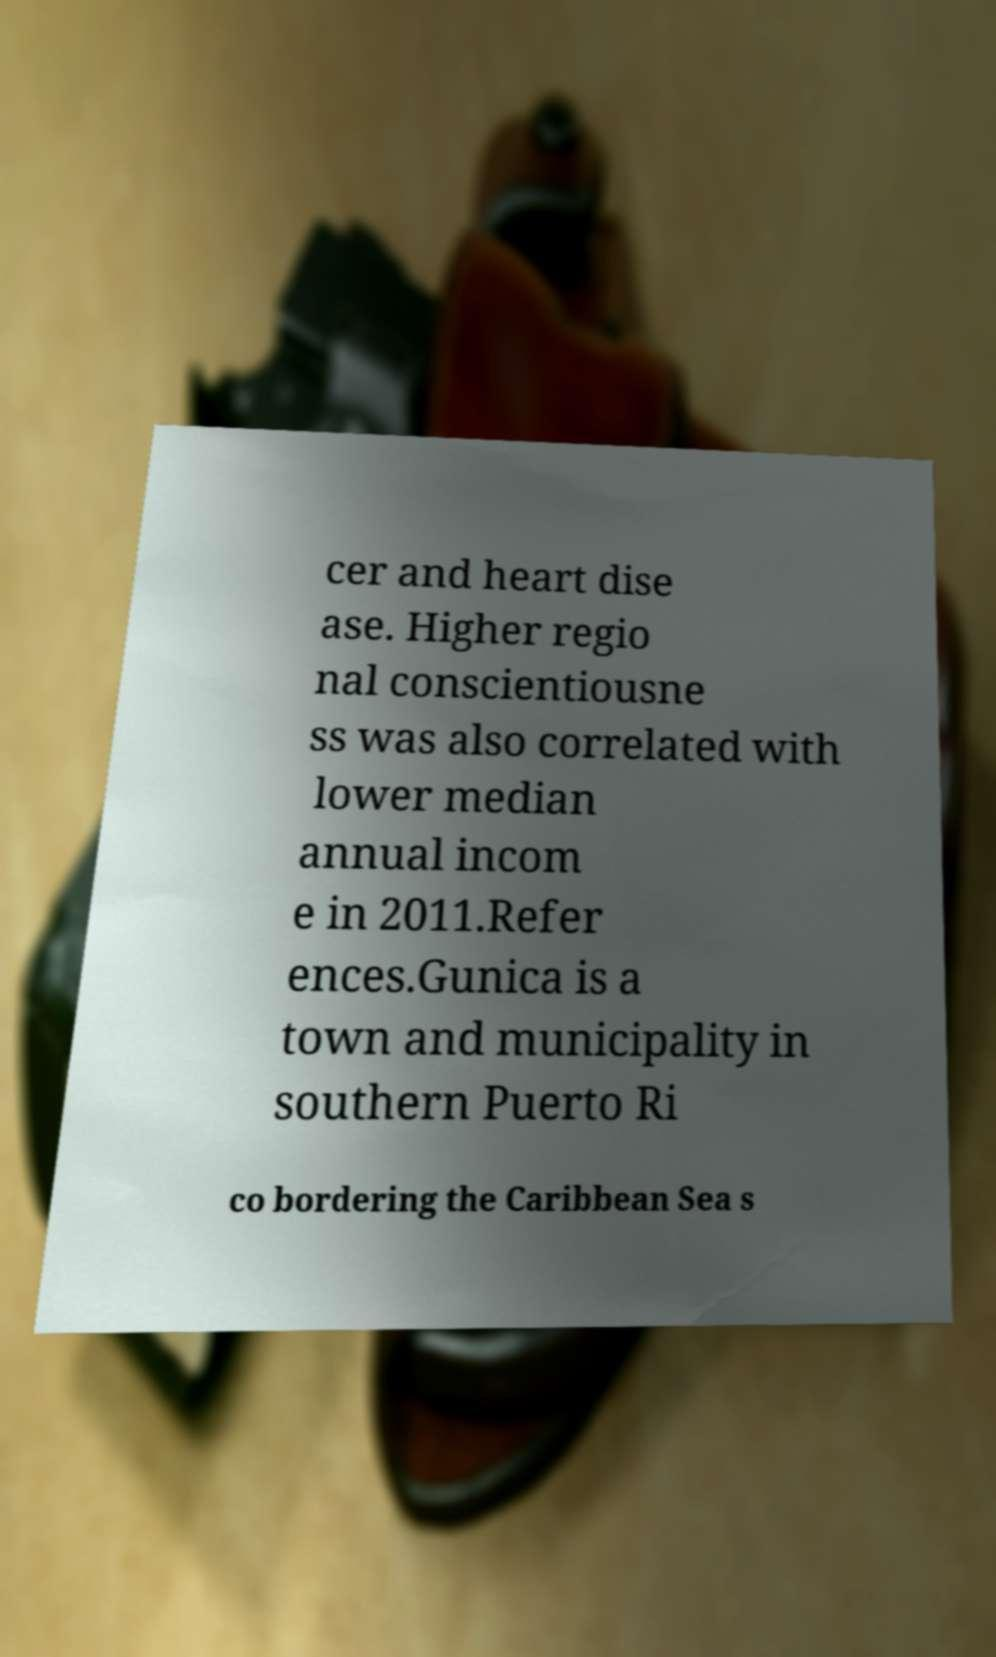For documentation purposes, I need the text within this image transcribed. Could you provide that? cer and heart dise ase. Higher regio nal conscientiousne ss was also correlated with lower median annual incom e in 2011.Refer ences.Gunica is a town and municipality in southern Puerto Ri co bordering the Caribbean Sea s 